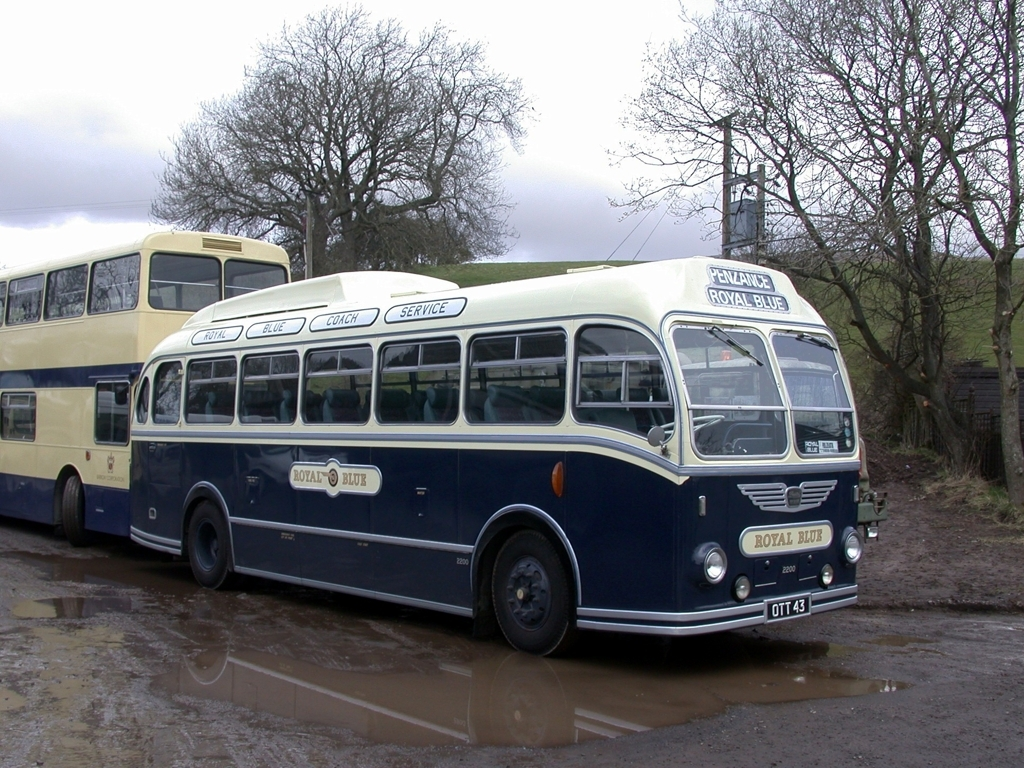Is the color of the image biased towards a cool tone? The predominant colors in the image, such as the blue and white hues of the vintage buses, generally contribute to a cooler tone. However, the presence of neutral tones like the grey road and the brown background foliage provides a balance, making the overall tone of the image not solely cool but rather a mix of cool and neutral colors. 